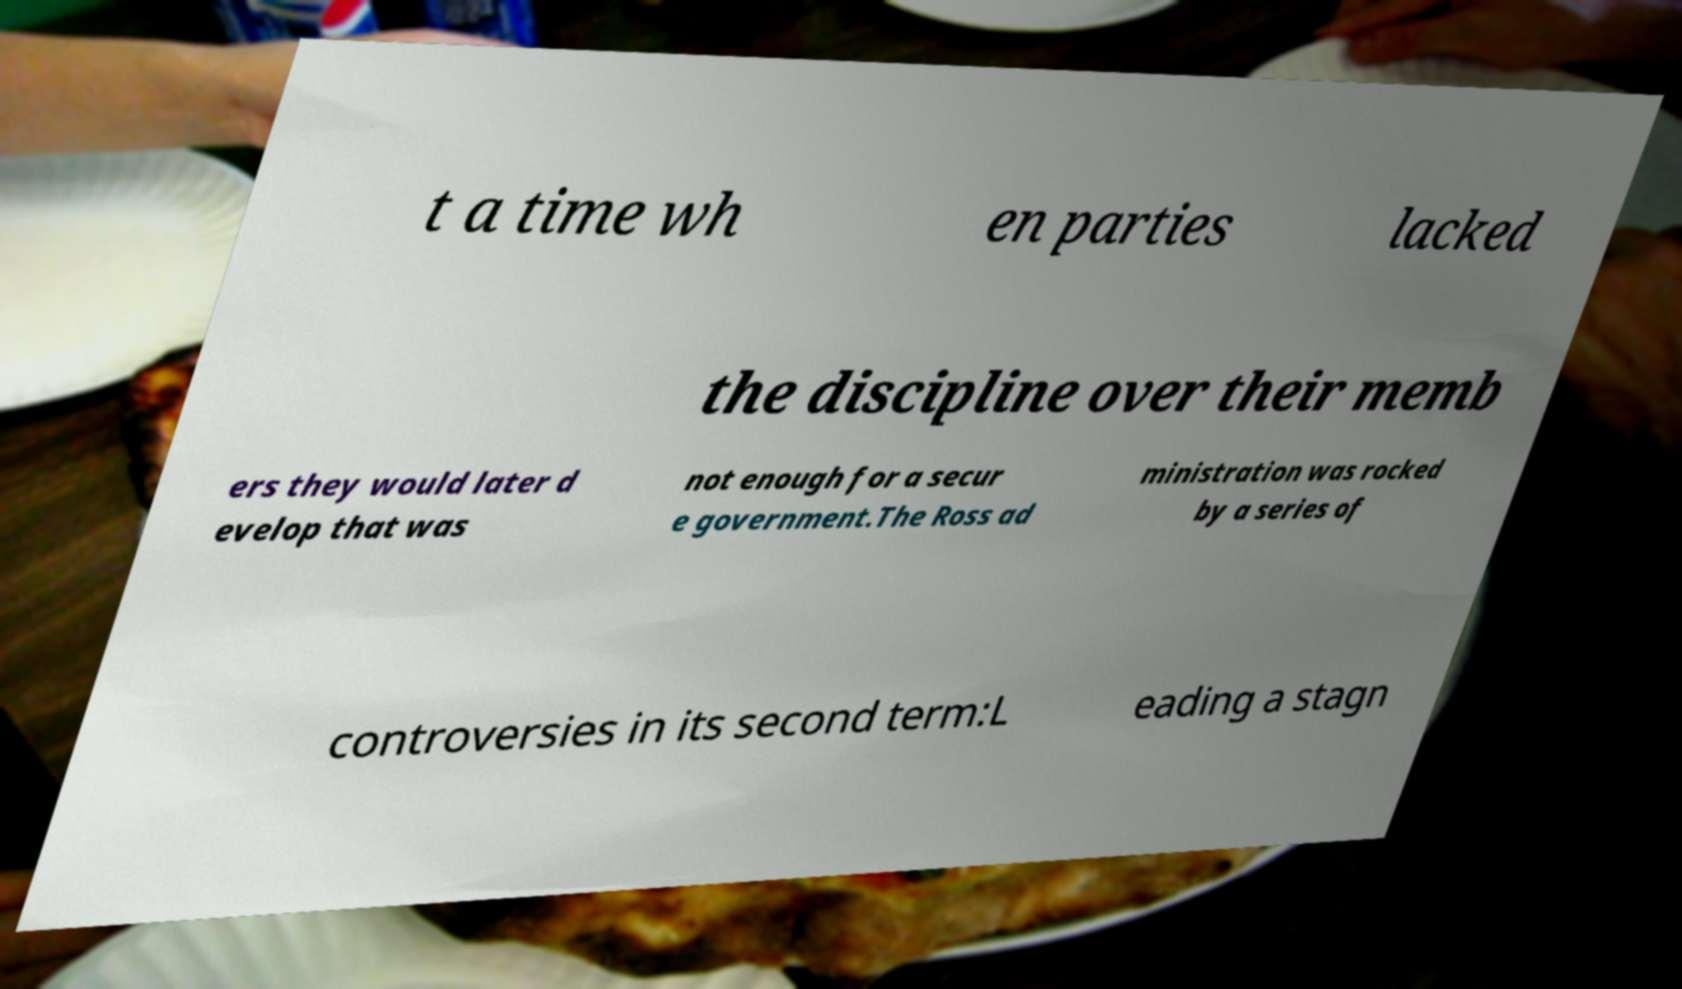What messages or text are displayed in this image? I need them in a readable, typed format. t a time wh en parties lacked the discipline over their memb ers they would later d evelop that was not enough for a secur e government.The Ross ad ministration was rocked by a series of controversies in its second term:L eading a stagn 